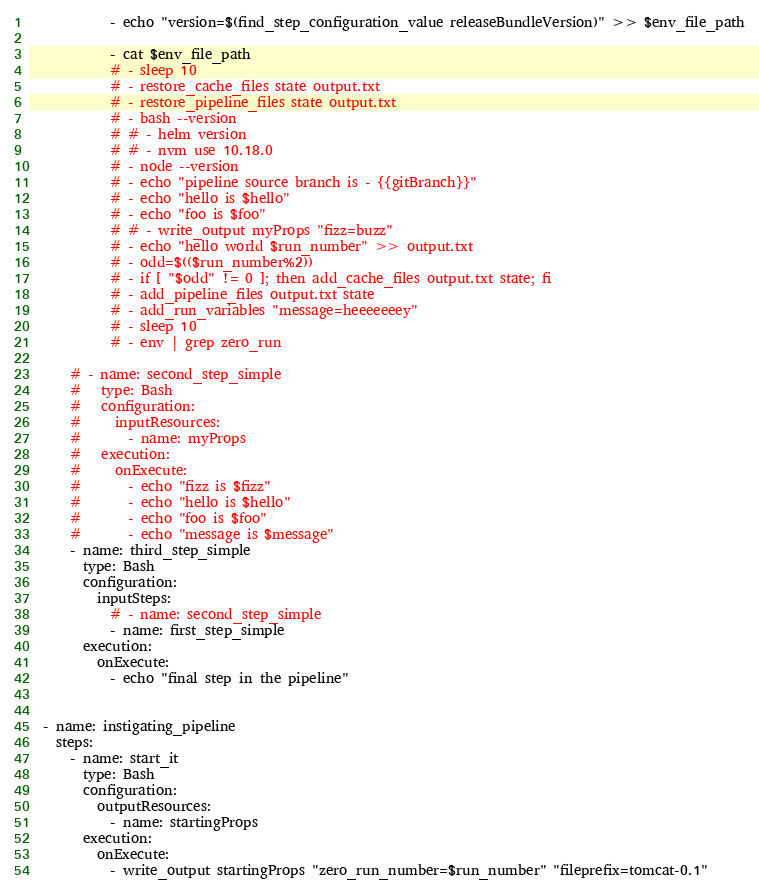<code> <loc_0><loc_0><loc_500><loc_500><_YAML_>            - echo "version=$(find_step_configuration_value releaseBundleVersion)" >> $env_file_path

            - cat $env_file_path
            # - sleep 10
            # - restore_cache_files state output.txt
            # - restore_pipeline_files state output.txt
            # - bash --version
            # # - helm version
            # # - nvm use 10.18.0
            # - node --version
            # - echo "pipeline source branch is - {{gitBranch}}"
            # - echo "hello is $hello"
            # - echo "foo is $foo"
            # # - write_output myProps "fizz=buzz"
            # - echo "hello world $run_number" >> output.txt
            # - odd=$(($run_number%2))
            # - if [ "$odd" != 0 ]; then add_cache_files output.txt state; fi
            # - add_pipeline_files output.txt state
            # - add_run_variables "message=heeeeeeey"
            # - sleep 10
            # - env | grep zero_run

      # - name: second_step_simple
      #   type: Bash
      #   configuration:
      #     inputResources:
      #       - name: myProps
      #   execution:
      #     onExecute:
      #       - echo "fizz is $fizz"
      #       - echo "hello is $hello"
      #       - echo "foo is $foo"
      #       - echo "message is $message"
      - name: third_step_simple
        type: Bash
        configuration:
          inputSteps:
            # - name: second_step_simple
            - name: first_step_simple
        execution:
          onExecute:
            - echo "final step in the pipeline"


  - name: instigating_pipeline
    steps:
      - name: start_it
        type: Bash
        configuration:
          outputResources:
            - name: startingProps
        execution:
          onExecute:
            - write_output startingProps "zero_run_number=$run_number" "fileprefix=tomcat-0.1"
</code> 